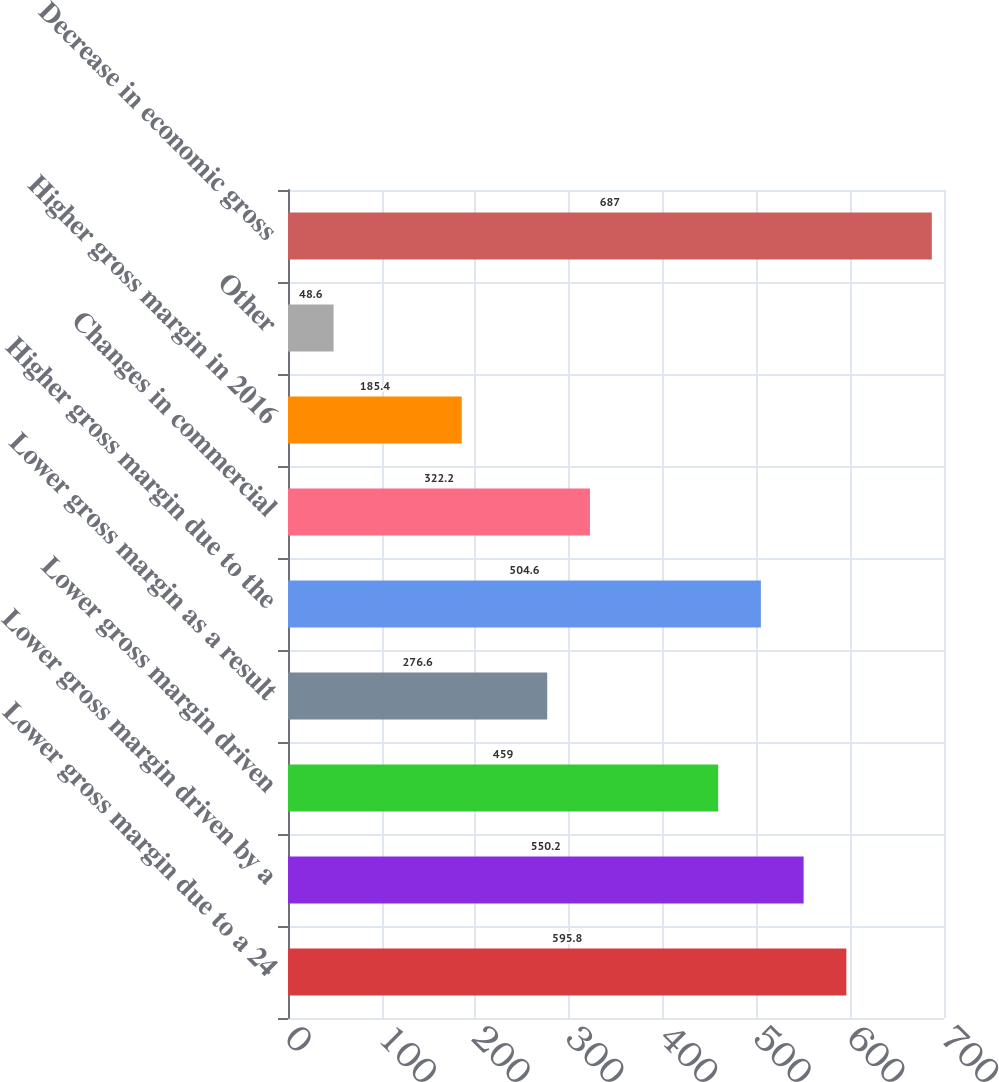<chart> <loc_0><loc_0><loc_500><loc_500><bar_chart><fcel>Lower gross margin due to a 24<fcel>Lower gross margin driven by a<fcel>Lower gross margin driven<fcel>Lower gross margin as a result<fcel>Higher gross margin due to the<fcel>Changes in commercial<fcel>Higher gross margin in 2016<fcel>Other<fcel>Decrease in economic gross<nl><fcel>595.8<fcel>550.2<fcel>459<fcel>276.6<fcel>504.6<fcel>322.2<fcel>185.4<fcel>48.6<fcel>687<nl></chart> 